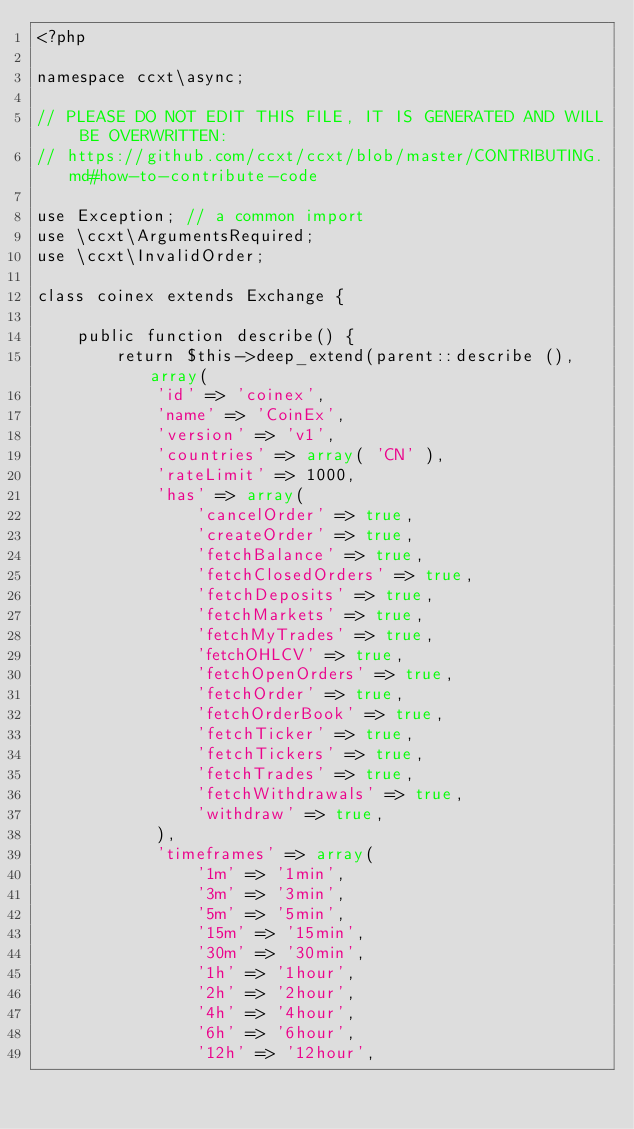<code> <loc_0><loc_0><loc_500><loc_500><_PHP_><?php

namespace ccxt\async;

// PLEASE DO NOT EDIT THIS FILE, IT IS GENERATED AND WILL BE OVERWRITTEN:
// https://github.com/ccxt/ccxt/blob/master/CONTRIBUTING.md#how-to-contribute-code

use Exception; // a common import
use \ccxt\ArgumentsRequired;
use \ccxt\InvalidOrder;

class coinex extends Exchange {

    public function describe() {
        return $this->deep_extend(parent::describe (), array(
            'id' => 'coinex',
            'name' => 'CoinEx',
            'version' => 'v1',
            'countries' => array( 'CN' ),
            'rateLimit' => 1000,
            'has' => array(
                'cancelOrder' => true,
                'createOrder' => true,
                'fetchBalance' => true,
                'fetchClosedOrders' => true,
                'fetchDeposits' => true,
                'fetchMarkets' => true,
                'fetchMyTrades' => true,
                'fetchOHLCV' => true,
                'fetchOpenOrders' => true,
                'fetchOrder' => true,
                'fetchOrderBook' => true,
                'fetchTicker' => true,
                'fetchTickers' => true,
                'fetchTrades' => true,
                'fetchWithdrawals' => true,
                'withdraw' => true,
            ),
            'timeframes' => array(
                '1m' => '1min',
                '3m' => '3min',
                '5m' => '5min',
                '15m' => '15min',
                '30m' => '30min',
                '1h' => '1hour',
                '2h' => '2hour',
                '4h' => '4hour',
                '6h' => '6hour',
                '12h' => '12hour',</code> 